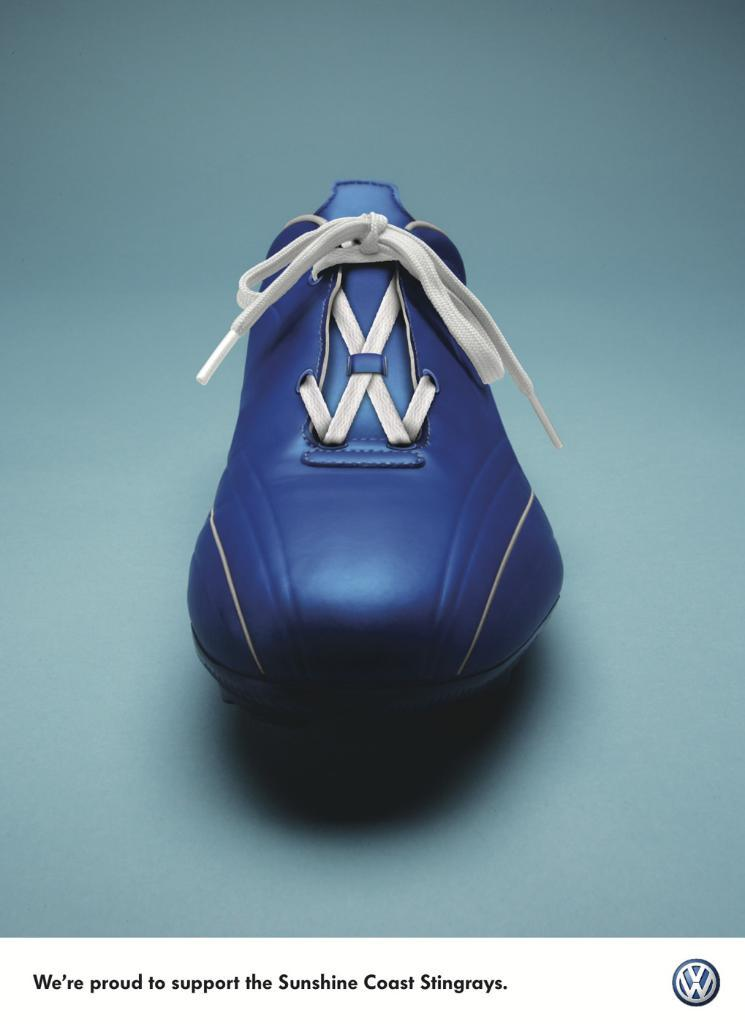<image>
Describe the image concisely. Volkswagen is proud to support the Sunshine Coast Stingrays. 